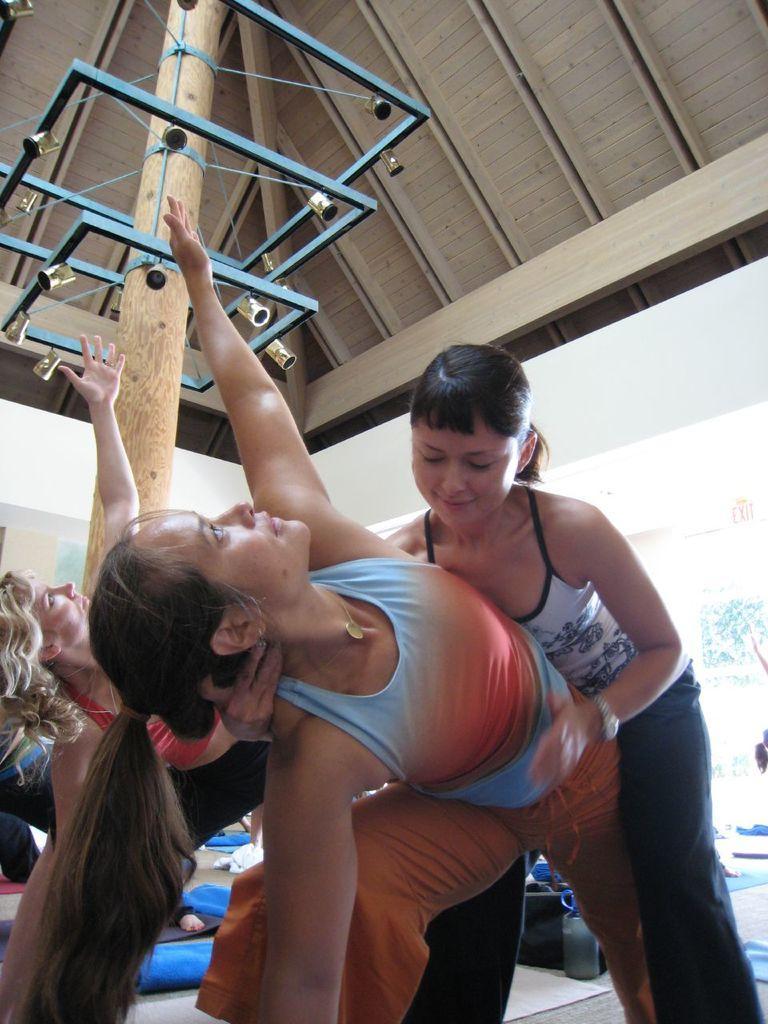Could you give a brief overview of what you see in this image? There is a group of people at the bottom of this image, and there is a wooden roof in the background. 